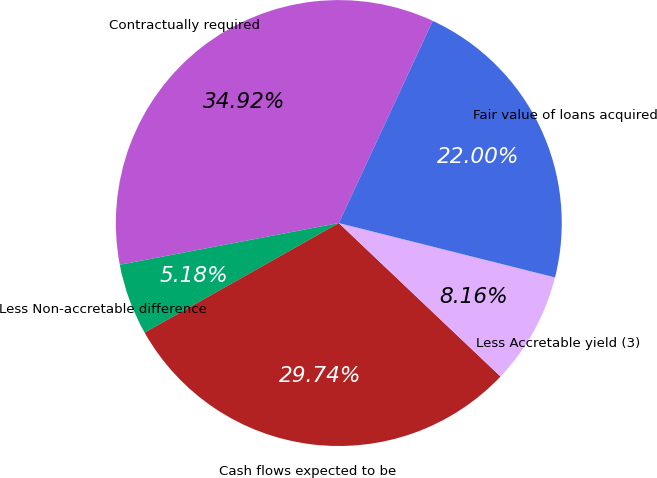Convert chart to OTSL. <chart><loc_0><loc_0><loc_500><loc_500><pie_chart><fcel>Contractually required<fcel>Less Non-accretable difference<fcel>Cash flows expected to be<fcel>Less Accretable yield (3)<fcel>Fair value of loans acquired<nl><fcel>34.92%<fcel>5.18%<fcel>29.74%<fcel>8.16%<fcel>22.0%<nl></chart> 